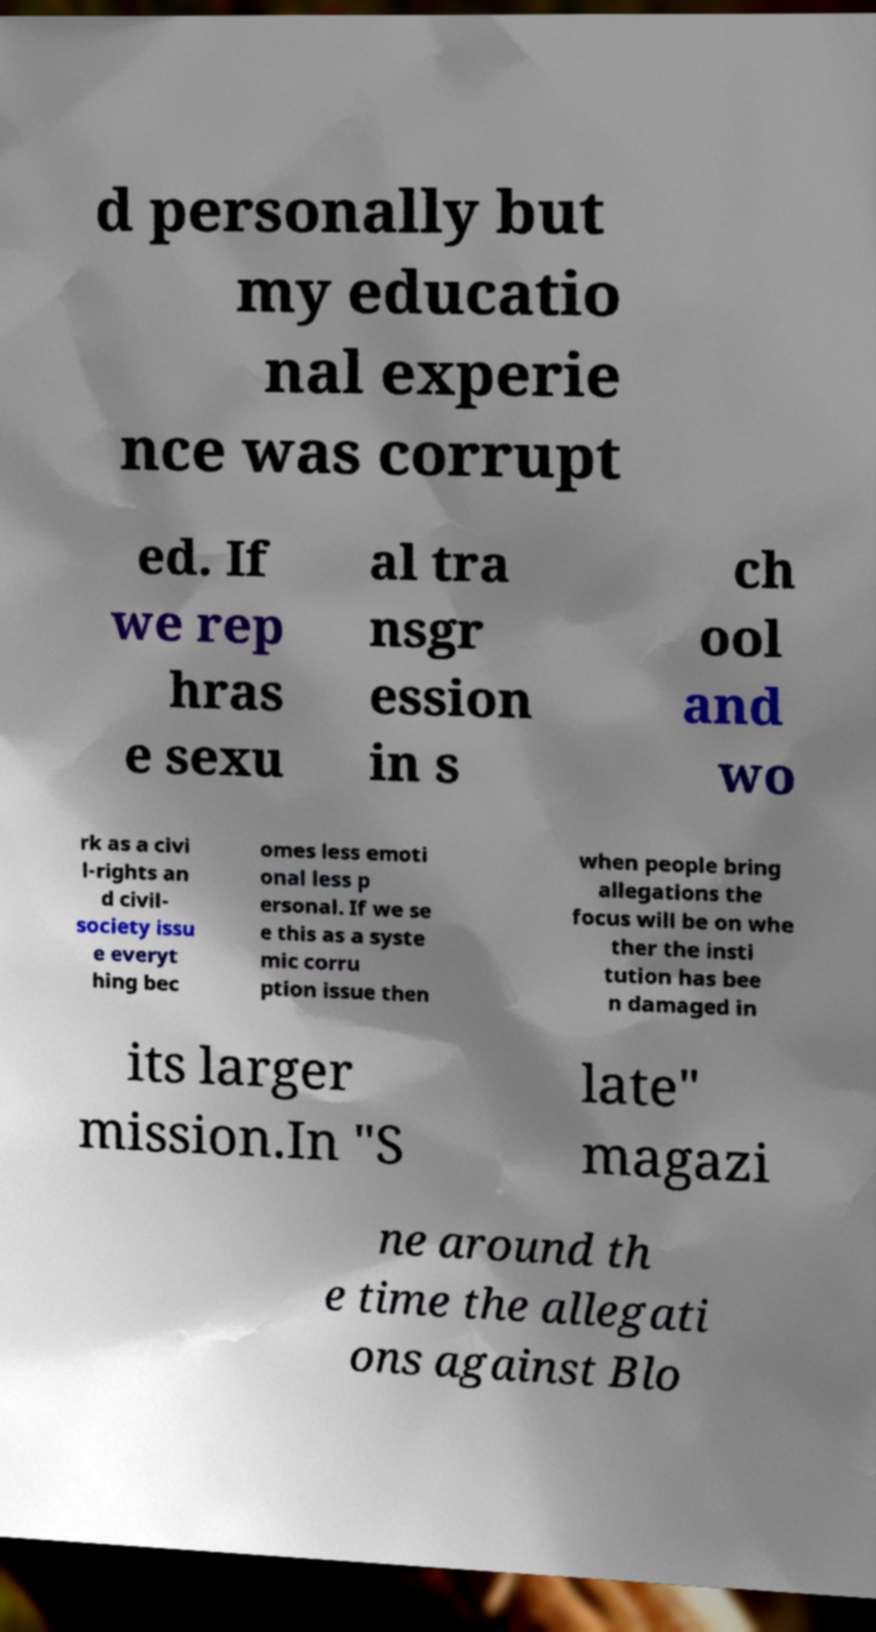For documentation purposes, I need the text within this image transcribed. Could you provide that? d personally but my educatio nal experie nce was corrupt ed. If we rep hras e sexu al tra nsgr ession in s ch ool and wo rk as a civi l-rights an d civil- society issu e everyt hing bec omes less emoti onal less p ersonal. If we se e this as a syste mic corru ption issue then when people bring allegations the focus will be on whe ther the insti tution has bee n damaged in its larger mission.In "S late" magazi ne around th e time the allegati ons against Blo 